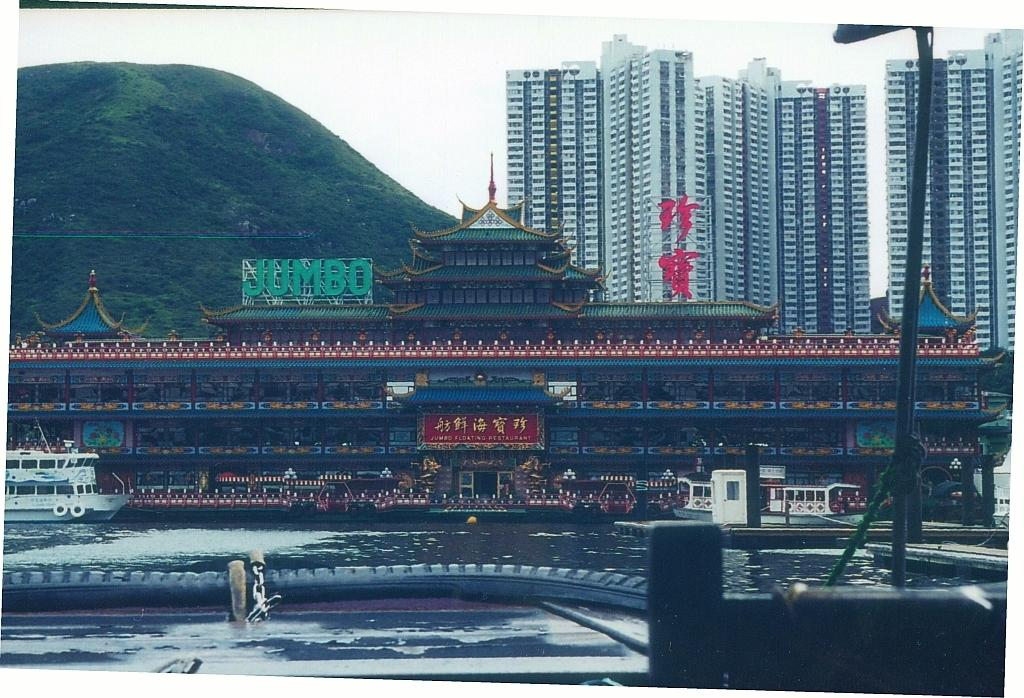What type of structures can be seen in the image? There is a group of buildings in the image. What is located in the water in the image? Boats are placed in the water in the image. Where is the pole located in the image? There is a pole on the right side of the water in the image. What can be seen in the distance in the image? There is a mountain visible in the background of the image. What is visible above the buildings and boats in the image? The sky is visible in the background of the image. How many alleys are present in the image? There is no alley present in the image. What type of stick is being used by the people in the image? There are no people or sticks visible in the image. 